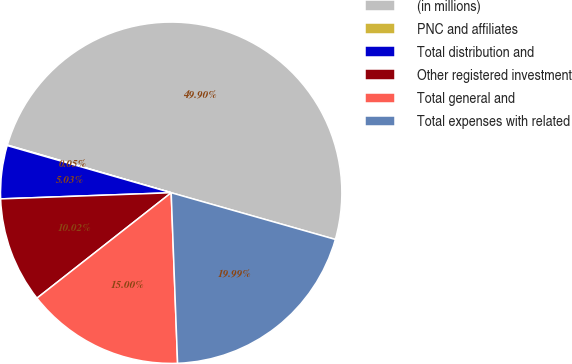<chart> <loc_0><loc_0><loc_500><loc_500><pie_chart><fcel>(in millions)<fcel>PNC and affiliates<fcel>Total distribution and<fcel>Other registered investment<fcel>Total general and<fcel>Total expenses with related<nl><fcel>49.9%<fcel>0.05%<fcel>5.03%<fcel>10.02%<fcel>15.0%<fcel>19.99%<nl></chart> 